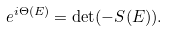Convert formula to latex. <formula><loc_0><loc_0><loc_500><loc_500>e ^ { i \Theta ( E ) } = \det ( - S ( E ) ) .</formula> 